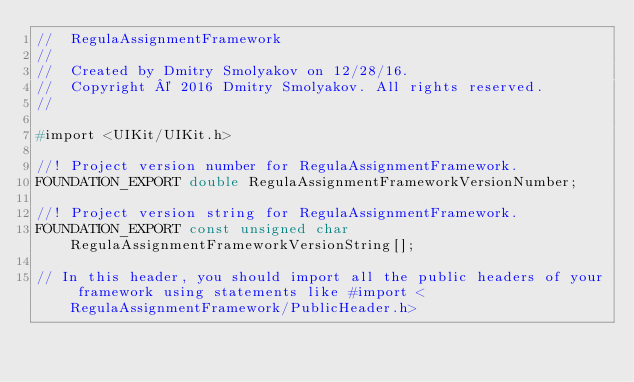<code> <loc_0><loc_0><loc_500><loc_500><_C_>//  RegulaAssignmentFramework
//
//  Created by Dmitry Smolyakov on 12/28/16.
//  Copyright © 2016 Dmitry Smolyakov. All rights reserved.
//

#import <UIKit/UIKit.h>

//! Project version number for RegulaAssignmentFramework.
FOUNDATION_EXPORT double RegulaAssignmentFrameworkVersionNumber;

//! Project version string for RegulaAssignmentFramework.
FOUNDATION_EXPORT const unsigned char RegulaAssignmentFrameworkVersionString[];

// In this header, you should import all the public headers of your framework using statements like #import <RegulaAssignmentFramework/PublicHeader.h>


</code> 